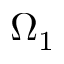<formula> <loc_0><loc_0><loc_500><loc_500>\Omega _ { 1 }</formula> 